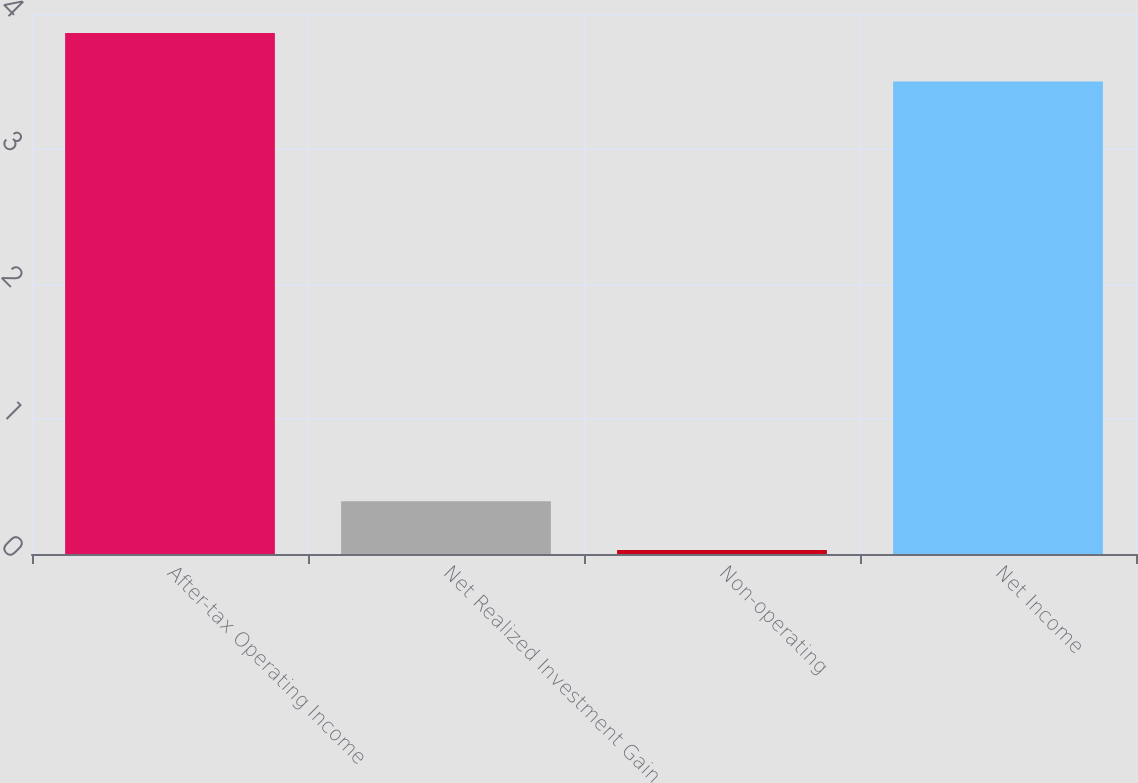Convert chart. <chart><loc_0><loc_0><loc_500><loc_500><bar_chart><fcel>After-tax Operating Income<fcel>Net Realized Investment Gain<fcel>Non-operating<fcel>Net Income<nl><fcel>3.86<fcel>0.39<fcel>0.03<fcel>3.5<nl></chart> 